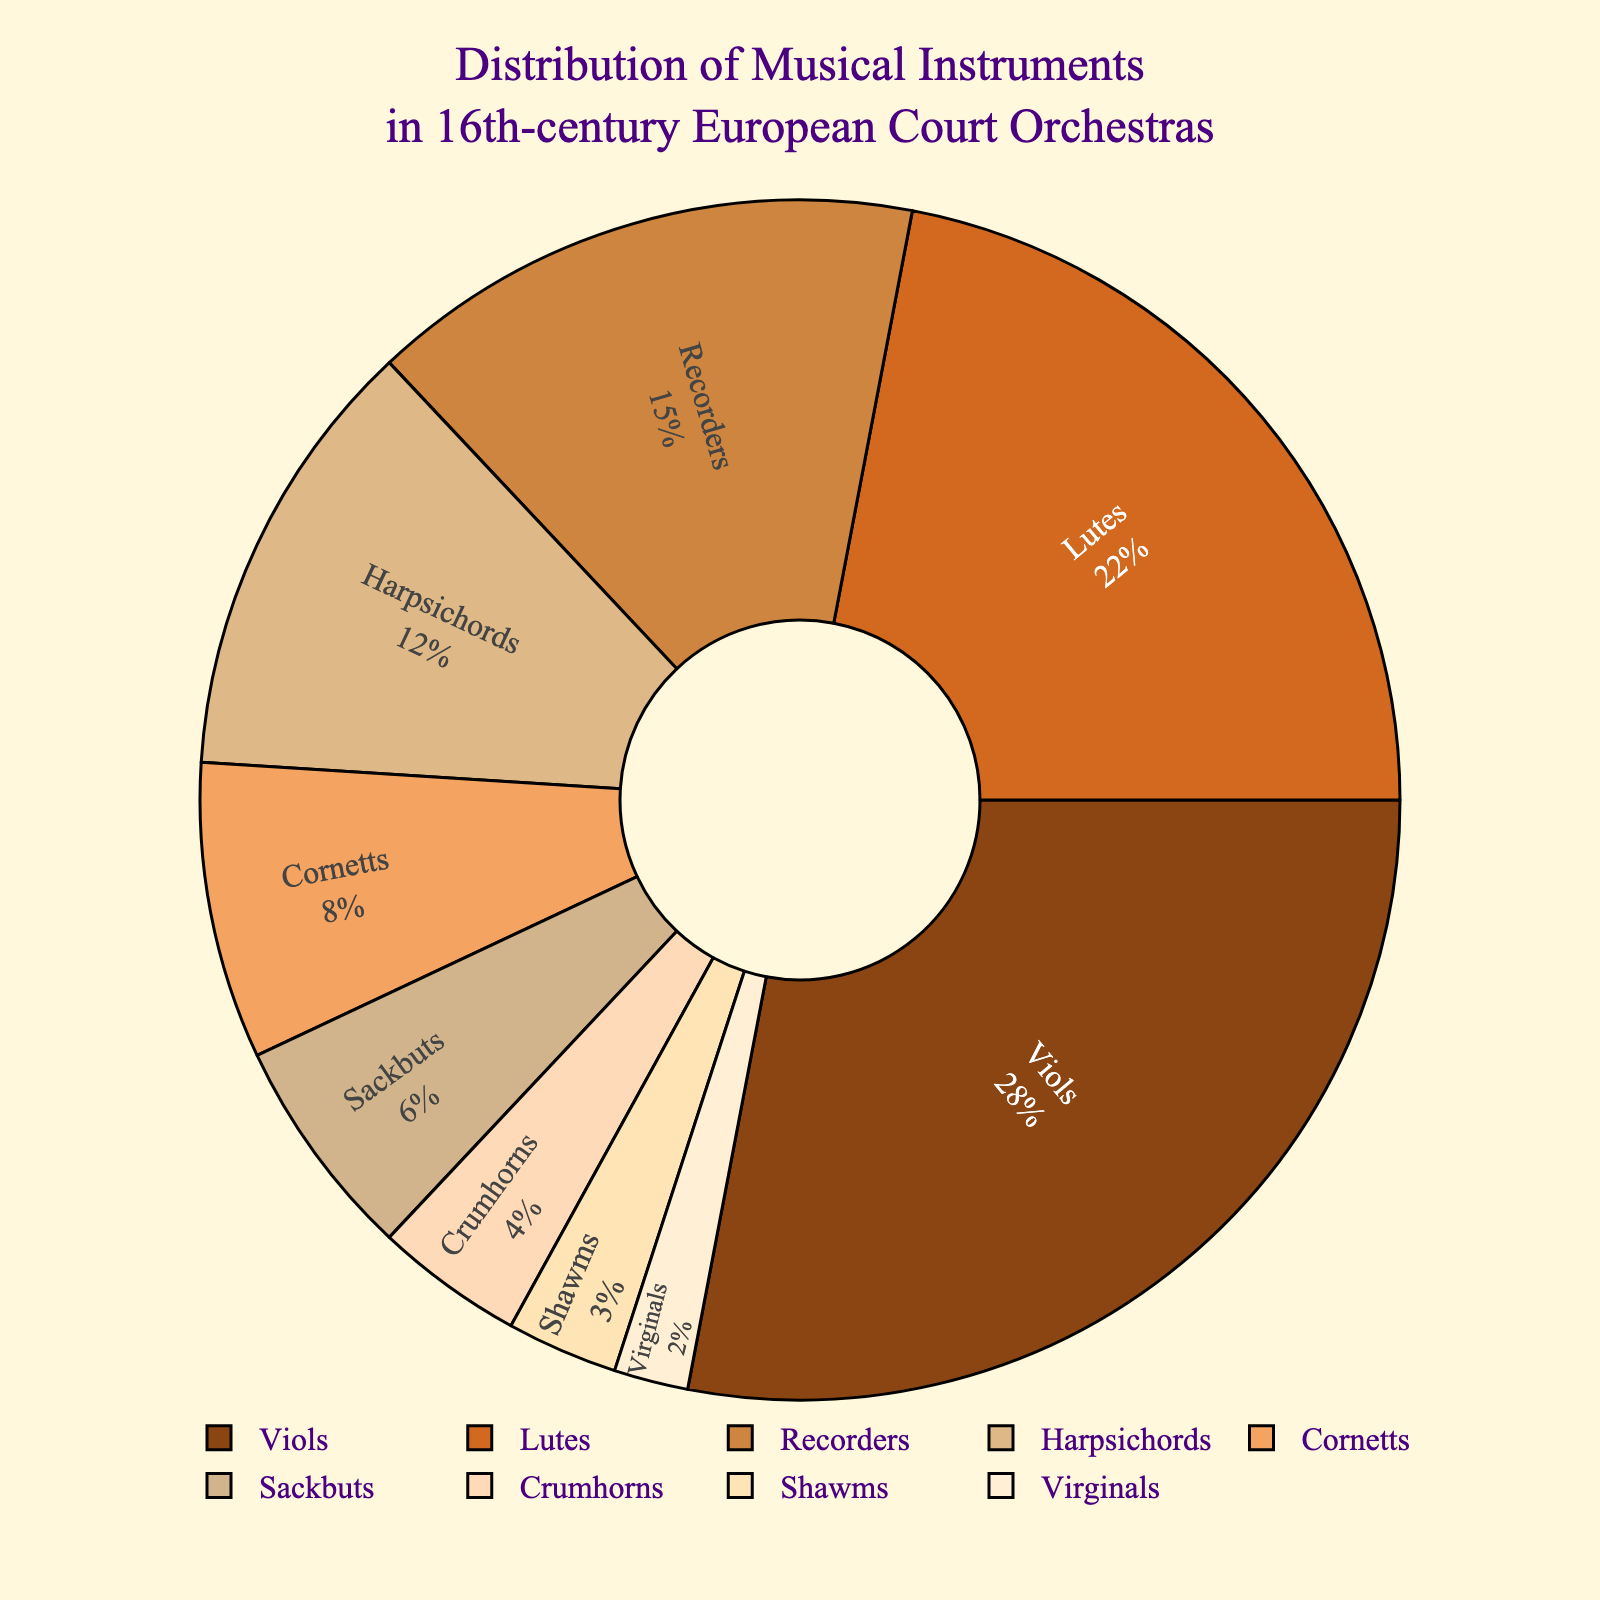Which instrument type constitutes the largest proportion in the 16th-century European court orchestras? To find the answer, look for the instrument type with the largest percentage labeled in the pie chart. The largest portion is labeled as "Viols" with 28%.
Answer: Viols What is the combined percentage of Lutes, Recorders, and Harpsichords? Add the given percentages of Lutes (22%), Recorders (15%), and Harpsichords (12%). The calculation is 22% + 15% + 12% = 49%.
Answer: 49% Which instruments have a representation of less than 5%? Identify all the instrument types with percentages below 5% as indicated in the pie chart. The instruments listed are Crumhorns (4%), Shawms (3%), and Virginals (2%).
Answer: Crumhorns, Shawms, Virginals Is the proportion of Viols greater than the combined proportion of Cornetts and Sackbuts? Compare the percentage of Viols (28%) with the sum of percentages of Cornetts (8%) and Sackbuts (6%). The combined total for Cornetts and Sackbuts is 8% + 6% = 14%. Since 28% > 14%, the proportion of Viols is greater.
Answer: Yes How much smaller is the proportion of Sackbuts compared to Lutes? Subtract the percentage of Sackbuts (6%) from the percentage of Lutes (22%), which gives 22% - 6% = 16%.
Answer: 16% What is the second most represented instrument type? The second largest percentage after Viols (28%) is Lutes with 22%, as indicated in the pie chart.
Answer: Lutes Which segments are depicted in the two lightest colors? Observe the segments with the lightest colors based on visual inspection. These segments correspond to Shawms (3%) and Virginals (2%).
Answer: Shawms, Virginals If the percentage of Harpsichords doubled, would it surpass the percentage of Viols? First, double the percentage of Harpsichords (12%), which gives 24%. Compare this with Viols (28%). Since 24% is still less than 28%, it would not surpass Viols.
Answer: No What is the total percentage of wind instruments (Recorders, Cornetts, Sackbuts, Crumhorns, Shawms)? Sum the percentages of all mentioned wind instruments: Recorders (15%) + Cornetts (8%) + Sackbuts (6%) + Crumhorns (4%) + Shawms (3%) = 36%.
Answer: 36% Which instrument types form the majority, i.e., together make up more than 50% of the distribution? Add up the percentages of the largest segments until the total exceeds 50%. Viols (28%) + Lutes (22%) = 50%. Therefore, Viols and Lutes together form exactly 50%, and since no combination by adding more instruments in increasing order of percentage gets more than 50%, only these two together technically don't surpass but exactly meet 50%. Nonetheless, they can be included as forming the majority when added with even the smallest remaining segment.
Answer: Viols, Lutes 